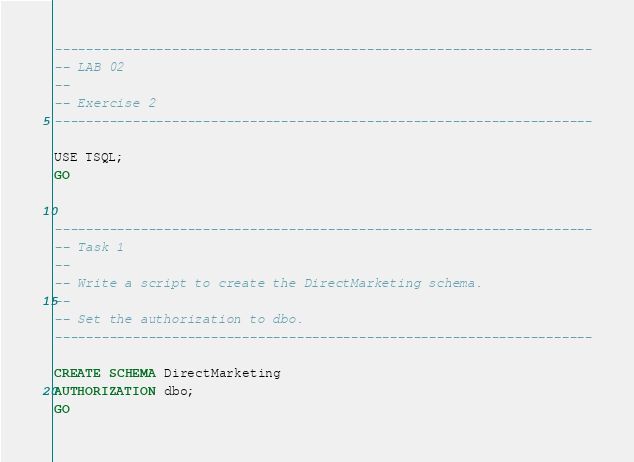Convert code to text. <code><loc_0><loc_0><loc_500><loc_500><_SQL_>---------------------------------------------------------------------
-- LAB 02
--
-- Exercise 2
---------------------------------------------------------------------

USE TSQL;
GO


---------------------------------------------------------------------
-- Task 1
-- 
-- Write a script to create the DirectMarketing schema.
--
-- Set the authorization to dbo.
---------------------------------------------------------------------

CREATE SCHEMA DirectMarketing
AUTHORIZATION dbo;
GO


</code> 